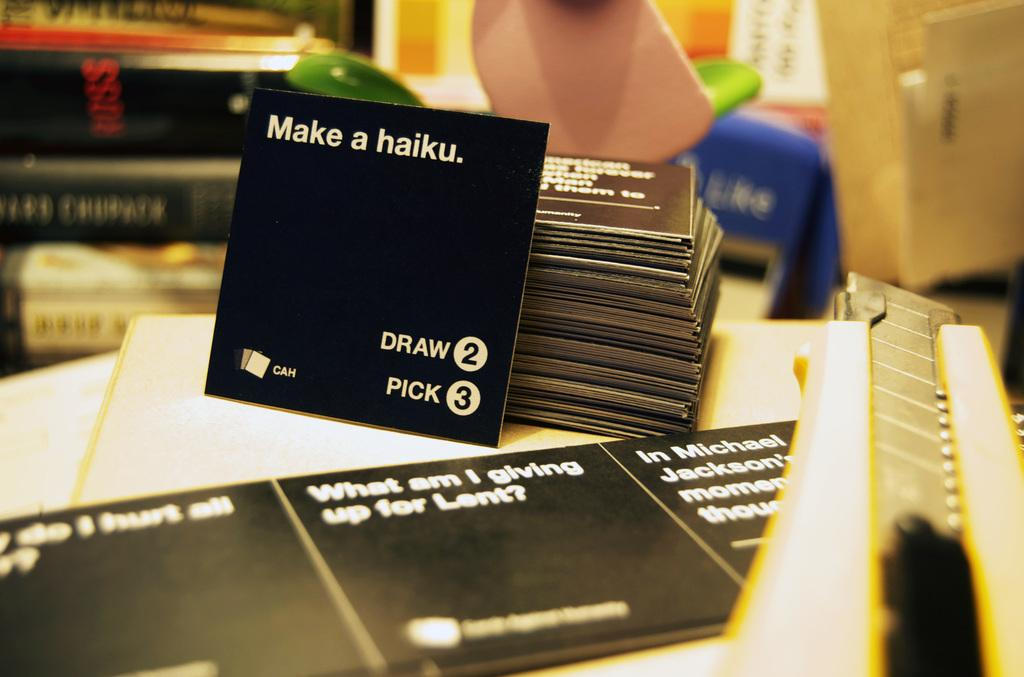<image>
Describe the image concisely. Books and cards such as make a haiku piled up, along with a utility knife. 